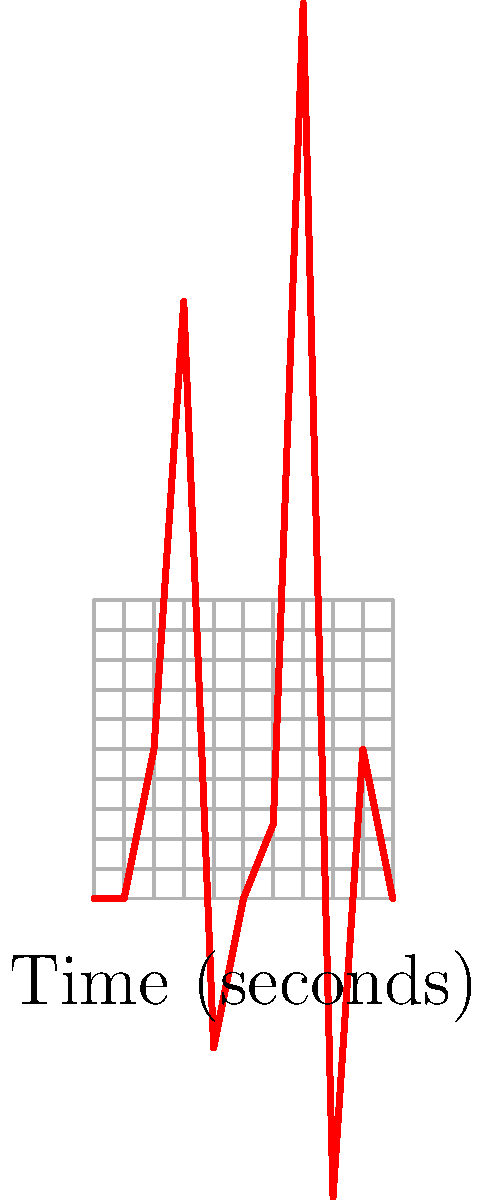Examine the ECG waveform provided. Which of the following cardiac conditions is most likely represented by the abnormal T wave morphology and the presence of a prominent U wave?

A) Left ventricular hypertrophy
B) Hypokalemia
C) Right bundle branch block
D) Acute myocardial infarction To interpret this complex ECG and identify the most likely cardiac condition, let's analyze the key features step-by-step:

1. T wave morphology: The T wave (represented by the deflection at 0.6-0.7 seconds) appears flattened and slightly prolonged.

2. U wave presence: There is a prominent positive deflection following the T wave (at around 0.8 seconds), which represents a U wave.

3. QRS complex: The QRS complex (sharp upward deflection at 0.3 seconds) appears normal in width and amplitude.

4. ST segment: There is no significant ST segment elevation or depression.

5. P wave: The P wave (small positive deflection at 0.2 seconds) appears normal.

Given these observations:

- The flattened T wave and prominent U wave are classic signs of hypokalemia (low potassium levels in the blood).
- There's no evidence of QRS widening or "rabbit ear" morphology typical of right bundle branch block.
- The absence of ST segment changes makes acute myocardial infarction less likely.
- While left ventricular hypertrophy can cause T wave changes, it typically presents with increased QRS amplitude, which is not seen here.

Therefore, the ECG findings are most consistent with hypokalemia. This electrolyte imbalance affects cardiac repolarization, leading to the characteristic T wave flattening and U wave prominence observed in this ECG.
Answer: Hypokalemia 